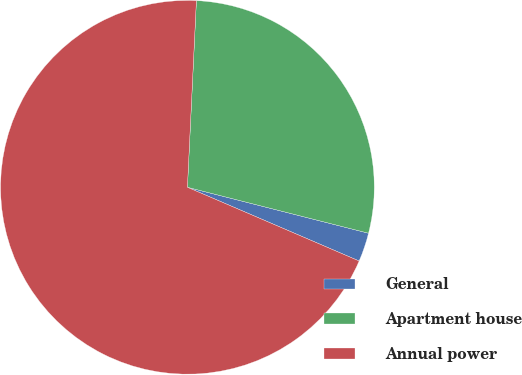Convert chart to OTSL. <chart><loc_0><loc_0><loc_500><loc_500><pie_chart><fcel>General<fcel>Apartment house<fcel>Annual power<nl><fcel>2.5%<fcel>28.19%<fcel>69.31%<nl></chart> 